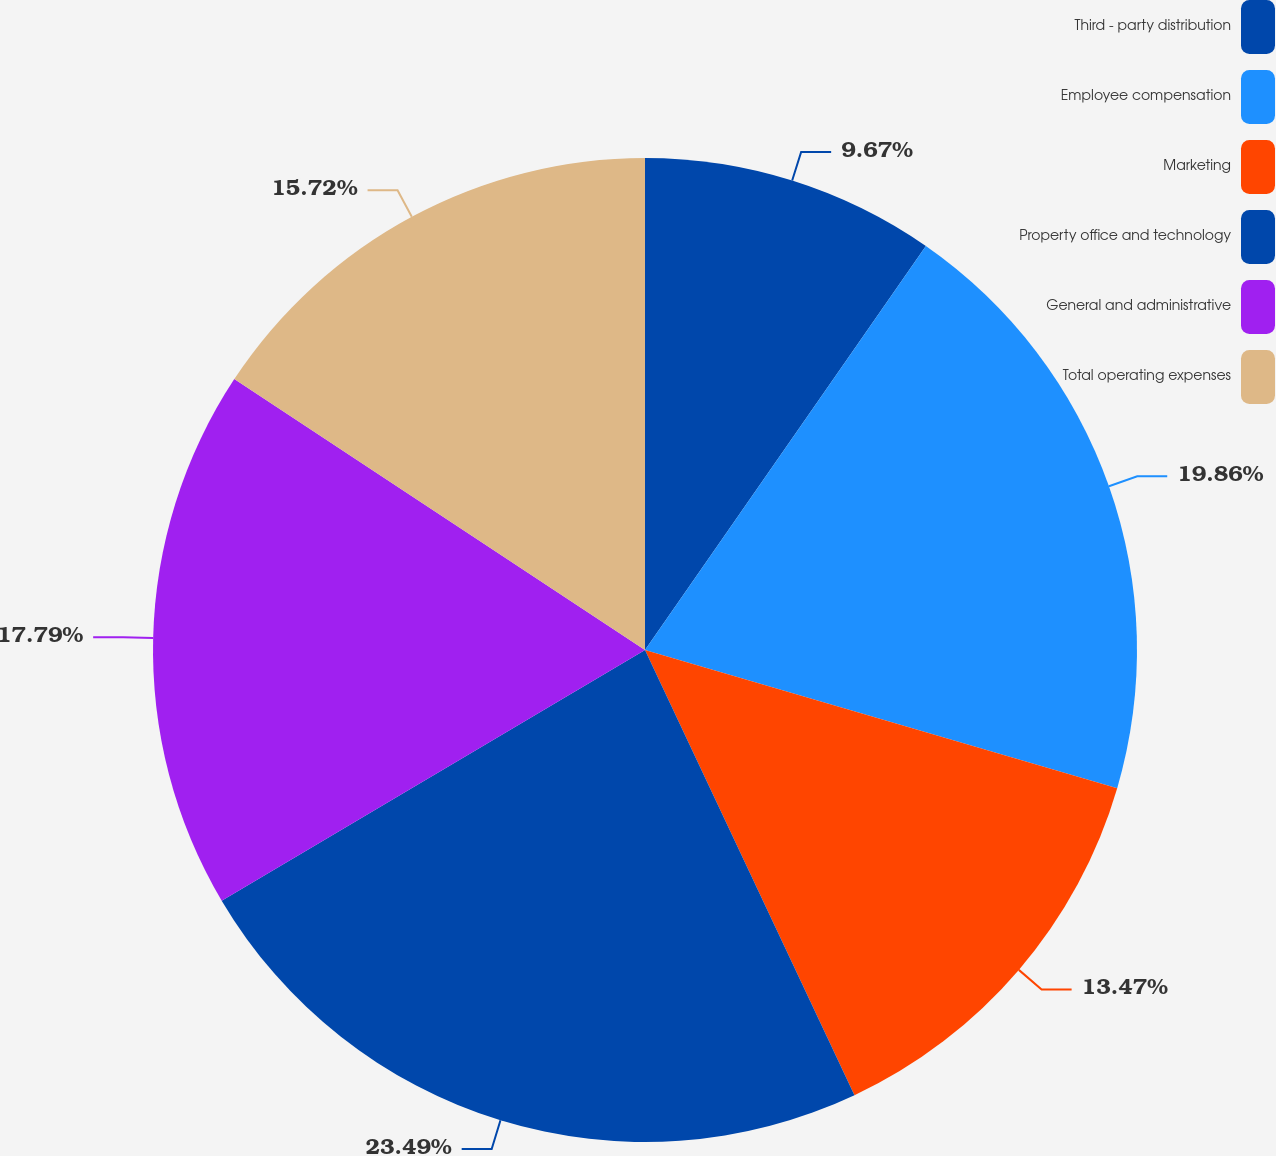Convert chart to OTSL. <chart><loc_0><loc_0><loc_500><loc_500><pie_chart><fcel>Third - party distribution<fcel>Employee compensation<fcel>Marketing<fcel>Property office and technology<fcel>General and administrative<fcel>Total operating expenses<nl><fcel>9.67%<fcel>19.86%<fcel>13.47%<fcel>23.49%<fcel>17.79%<fcel>15.72%<nl></chart> 